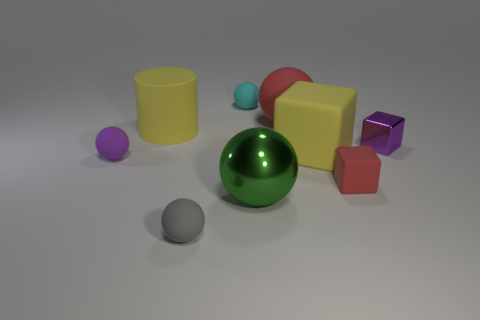Is there any other thing that has the same material as the green ball?
Your response must be concise. Yes. What is the color of the shiny thing right of the large shiny thing?
Give a very brief answer. Purple. Are the large cylinder and the large red ball that is right of the big green shiny ball made of the same material?
Your response must be concise. Yes. What is the small cyan thing made of?
Make the answer very short. Rubber. There is a small gray thing that is the same material as the tiny cyan object; what is its shape?
Provide a succinct answer. Sphere. How many other things are there of the same shape as the big shiny object?
Keep it short and to the point. 4. There is a green thing; what number of metal things are to the left of it?
Provide a succinct answer. 0. There is a rubber sphere on the right side of the big shiny ball; is its size the same as the red block to the right of the big cylinder?
Give a very brief answer. No. What number of other things are the same size as the gray object?
Keep it short and to the point. 4. What material is the big yellow thing that is left of the shiny thing that is left of the red rubber object that is on the right side of the big matte block made of?
Make the answer very short. Rubber. 